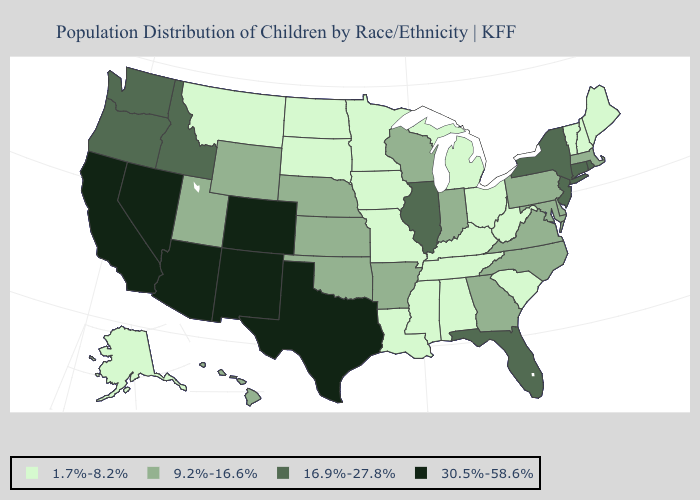What is the value of North Carolina?
Quick response, please. 9.2%-16.6%. What is the value of New Mexico?
Concise answer only. 30.5%-58.6%. Name the states that have a value in the range 1.7%-8.2%?
Short answer required. Alabama, Alaska, Iowa, Kentucky, Louisiana, Maine, Michigan, Minnesota, Mississippi, Missouri, Montana, New Hampshire, North Dakota, Ohio, South Carolina, South Dakota, Tennessee, Vermont, West Virginia. Does the first symbol in the legend represent the smallest category?
Quick response, please. Yes. Does Wisconsin have a higher value than Arizona?
Give a very brief answer. No. Name the states that have a value in the range 9.2%-16.6%?
Be succinct. Arkansas, Delaware, Georgia, Hawaii, Indiana, Kansas, Maryland, Massachusetts, Nebraska, North Carolina, Oklahoma, Pennsylvania, Utah, Virginia, Wisconsin, Wyoming. Among the states that border New Jersey , does Delaware have the lowest value?
Keep it brief. Yes. What is the lowest value in states that border Colorado?
Keep it brief. 9.2%-16.6%. How many symbols are there in the legend?
Keep it brief. 4. Among the states that border Mississippi , does Louisiana have the lowest value?
Concise answer only. Yes. What is the value of Vermont?
Keep it brief. 1.7%-8.2%. Name the states that have a value in the range 30.5%-58.6%?
Short answer required. Arizona, California, Colorado, Nevada, New Mexico, Texas. What is the value of West Virginia?
Short answer required. 1.7%-8.2%. Which states have the lowest value in the USA?
Quick response, please. Alabama, Alaska, Iowa, Kentucky, Louisiana, Maine, Michigan, Minnesota, Mississippi, Missouri, Montana, New Hampshire, North Dakota, Ohio, South Carolina, South Dakota, Tennessee, Vermont, West Virginia. What is the value of Georgia?
Concise answer only. 9.2%-16.6%. 